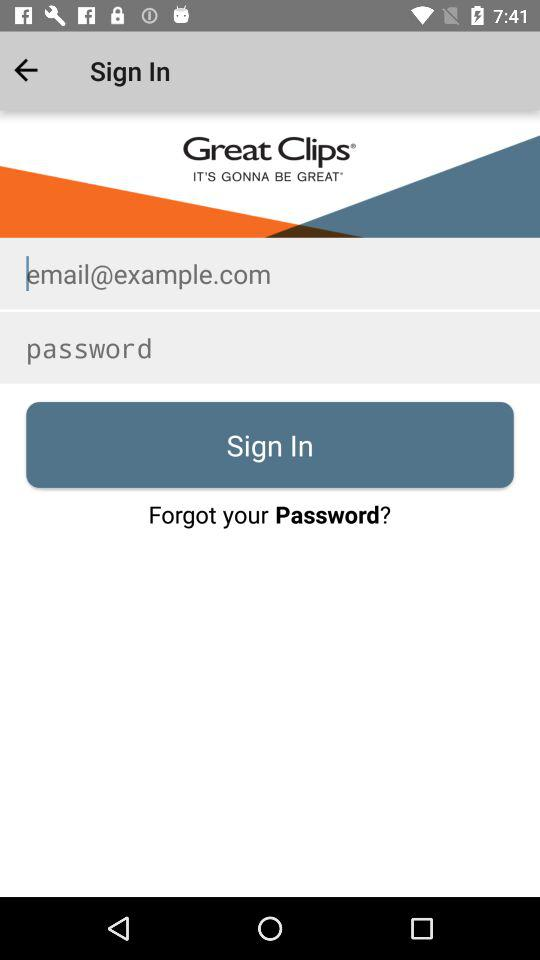What is the application name? The application name is "Great Clips". 